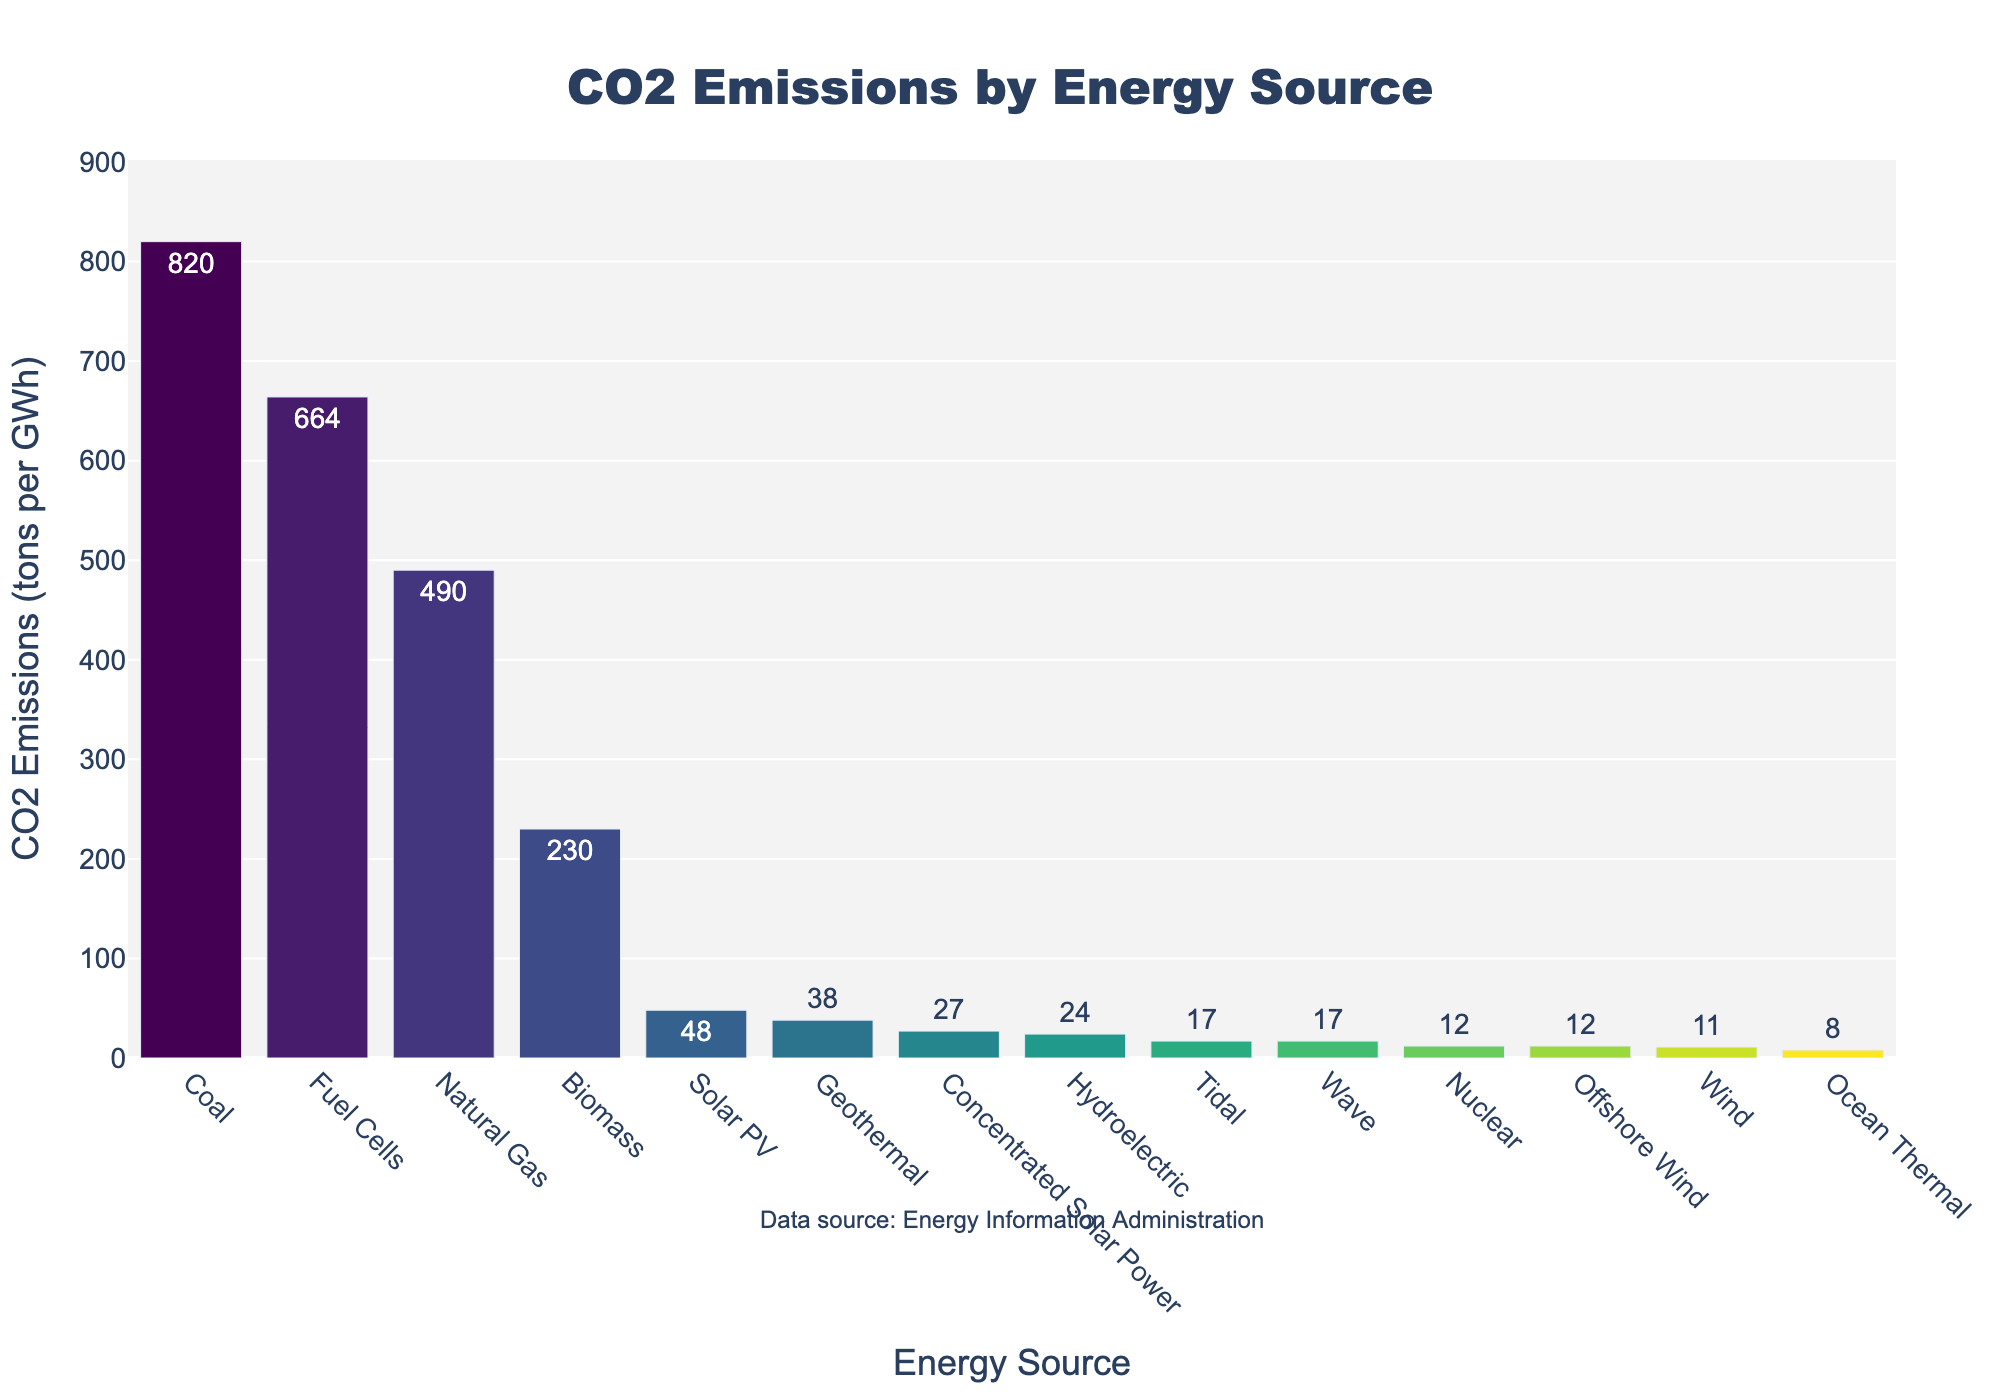Which energy source has the highest CO2 emissions per gigawatt-hour? The figure shows the CO2 emissions for each energy source. The bar representing "Coal" is the tallest. Hence, "Coal" has the highest CO2 emissions per gigawatt-hour.
Answer: Coal Which energy source has the lowest CO2 emissions per gigawatt-hour? The shortest bar corresponds to "Ocean Thermal," indicating it has the lowest CO2 emissions per gigawatt-hour.
Answer: Ocean Thermal How much less CO2 does wind power emit compared to natural gas per gigawatt-hour? The CO2 emissions for natural gas are 490 tons per gigawatt-hour, and for wind, it is 11 tons per gigawatt-hour. The difference is 490 - 11 = 479 tons per gigawatt-hour.
Answer: 479 tons per gigawatt-hour What is the combined CO2 emission of Tidal, Wave, and Ocean Thermal? The CO2 emissions for Tidal and Wave are 17 tons per gigawatt-hour each, and for Ocean Thermal, it is 8 tons per gigawatt-hour. Summing them up, 17 + 17 + 8 = 42.
Answer: 42 tons per gigawatt-hour Which is more polluting: Biomass or Natural Gas? The height of the bar for Biomass (230 tons per gigawatt-hour) is less than that for Natural Gas (490 tons per gigawatt-hour), so Natural Gas is more polluting.
Answer: Natural Gas How much less CO2 does Solar PV emit than Biomass per gigawatt-hour? The CO2 emissions for Biomass are 230 tons per gigawatt-hour, and for Solar PV, it is 48 tons per gigawatt-hour. The difference is 230 - 48 = 182 tons per gigawatt-hour.
Answer: 182 tons per gigawatt-hour What is the average CO2 emission of Solar PV, Wind, and Nuclear energy sources? The CO2 emissions for Solar PV, Wind, and Nuclear are 48, 11, and 12 tons per gigawatt-hour, respectively. The average is (48 + 11 + 12) / 3 = 71 / 3 ≈ 23.67 tons per gigawatt-hour.
Answer: 23.7 tons per gigawatt-hour Which energy sources have exactly the same CO2 emissions? By examining the bars, we see that Nuclear and Offshore Wind, as well as Tidal and Wave, have the same CO2 emissions: 12 and 17 tons per gigawatt-hour, respectively.
Answer: Nuclear and Offshore Wind; Tidal and Wave What is the difference in CO2 emissions between the most and least polluting energy sources? The most polluting energy source is Coal with 820 tons per gigawatt-hour and the least is Ocean Thermal with 8 tons per gigawatt-hour. The difference is 820 - 8 = 812 tons per gigawatt-hour.
Answer: 812 tons per gigawatt-hour 